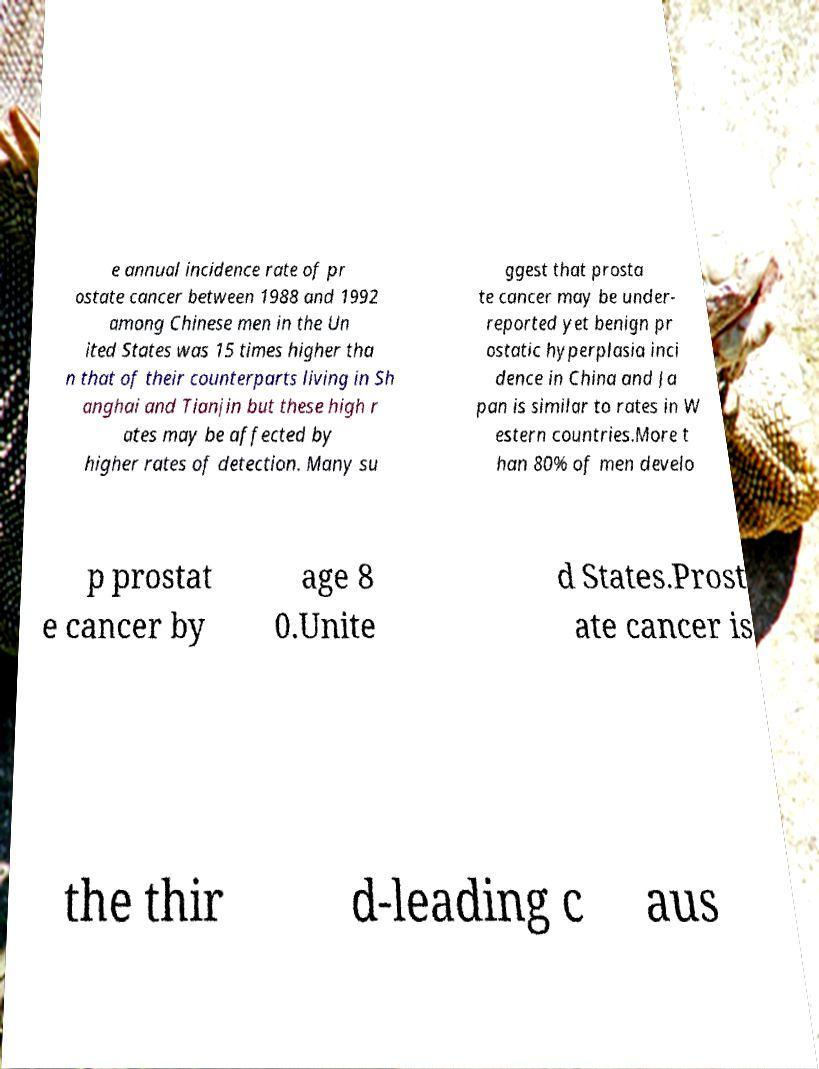For documentation purposes, I need the text within this image transcribed. Could you provide that? e annual incidence rate of pr ostate cancer between 1988 and 1992 among Chinese men in the Un ited States was 15 times higher tha n that of their counterparts living in Sh anghai and Tianjin but these high r ates may be affected by higher rates of detection. Many su ggest that prosta te cancer may be under- reported yet benign pr ostatic hyperplasia inci dence in China and Ja pan is similar to rates in W estern countries.More t han 80% of men develo p prostat e cancer by age 8 0.Unite d States.Prost ate cancer is the thir d-leading c aus 